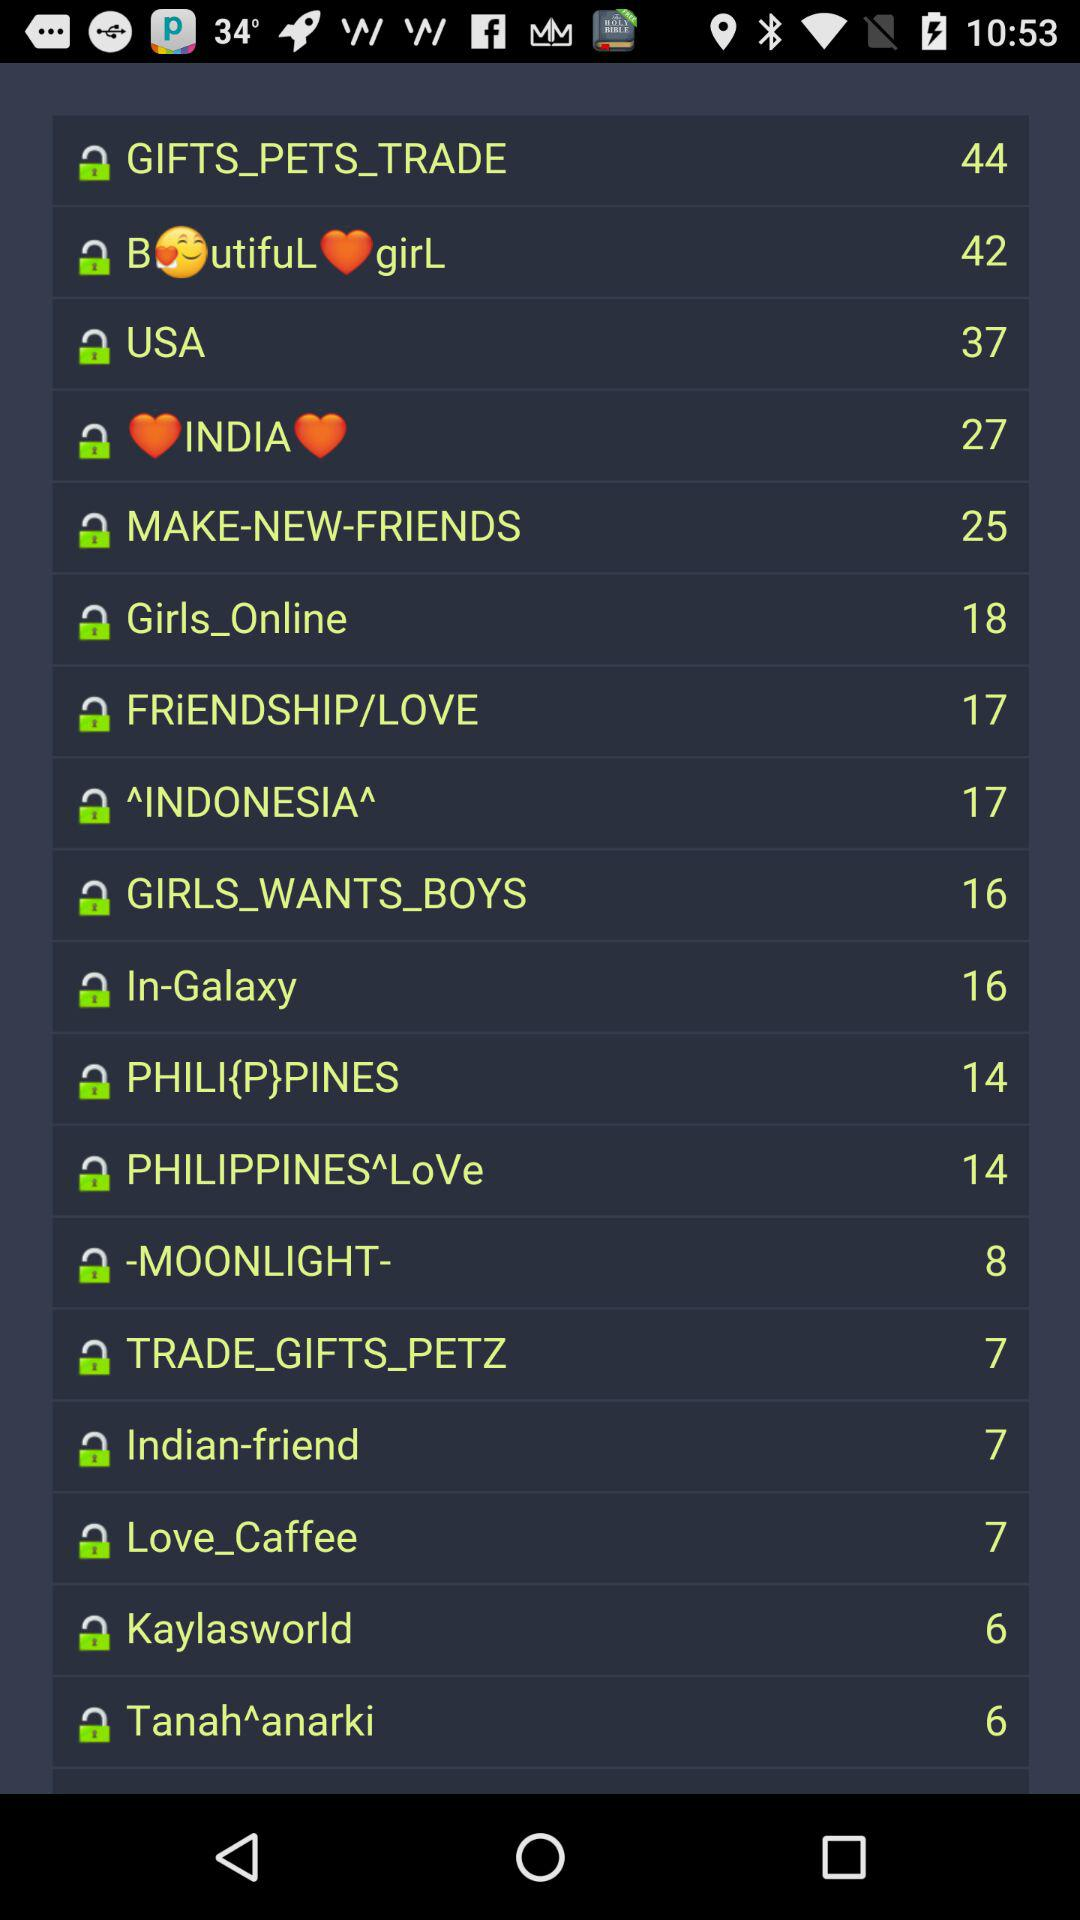What is the status of the Moonlight?
When the provided information is insufficient, respond with <no answer>. <no answer> 